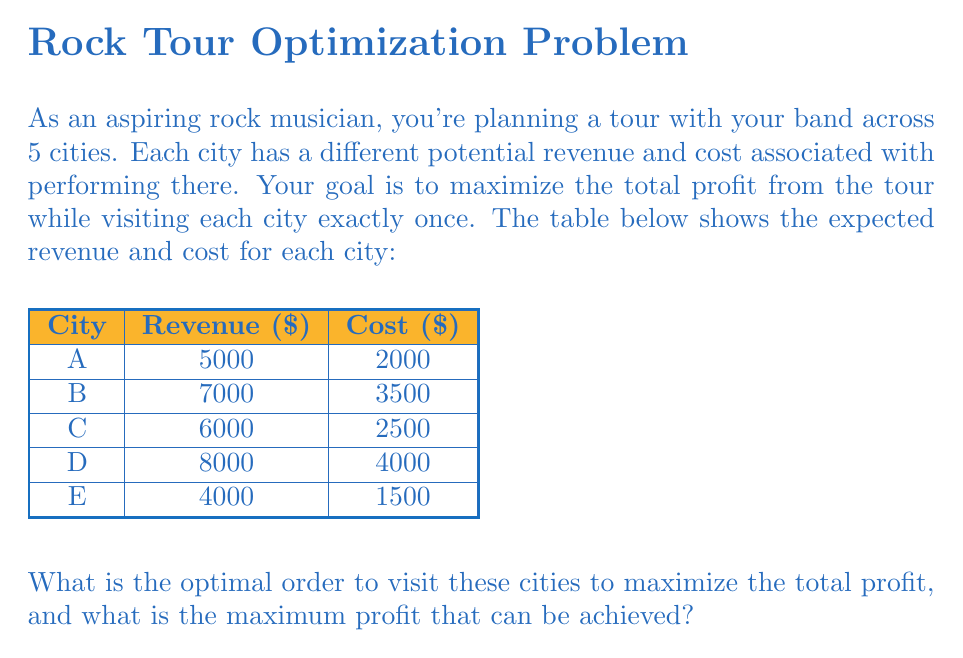Give your solution to this math problem. To solve this problem, we'll follow these steps:

1) Calculate the profit for each city:
   Profit = Revenue - Cost
   
   City A: $5000 - $2000 = $3000
   City B: $7000 - $3500 = $3500
   City C: $6000 - $2500 = $3500
   City D: $8000 - $4000 = $4000
   City E: $4000 - $1500 = $2500

2) Since we need to visit each city exactly once, the order of visits doesn't affect the total profit. The total profit will be the sum of individual profits regardless of the order.

3) Calculate the total profit:
   $$\text{Total Profit} = 3000 + 3500 + 3500 + 4000 + 2500 = $16,500$$

4) For the optimal order, we can arrange the cities from highest profit to lowest:
   D ($4000) → B ($3500) → C ($3500) → A ($3000) → E ($2500)

This order isn't necessary for maximizing profit, but it might be psychologically beneficial for the band to start with the most profitable shows and end with the least profitable.
Answer: Optimal order: D → B → C → A → E; Maximum profit: $16,500 